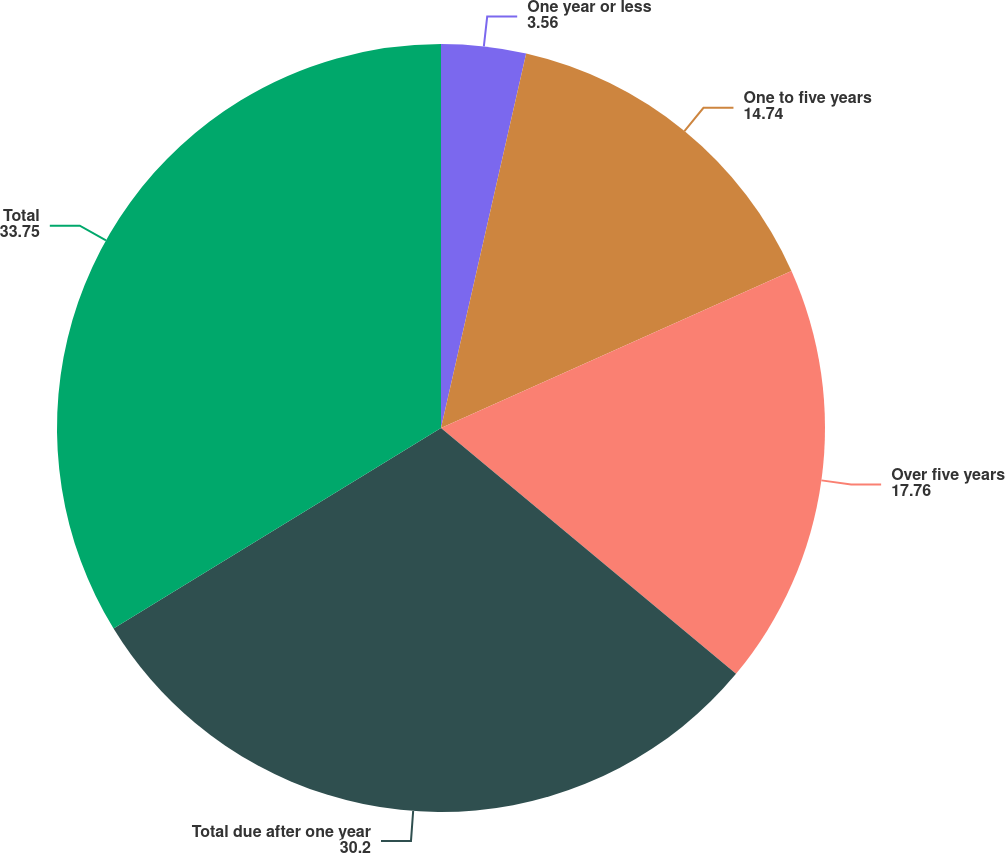<chart> <loc_0><loc_0><loc_500><loc_500><pie_chart><fcel>One year or less<fcel>One to five years<fcel>Over five years<fcel>Total due after one year<fcel>Total<nl><fcel>3.56%<fcel>14.74%<fcel>17.76%<fcel>30.2%<fcel>33.75%<nl></chart> 